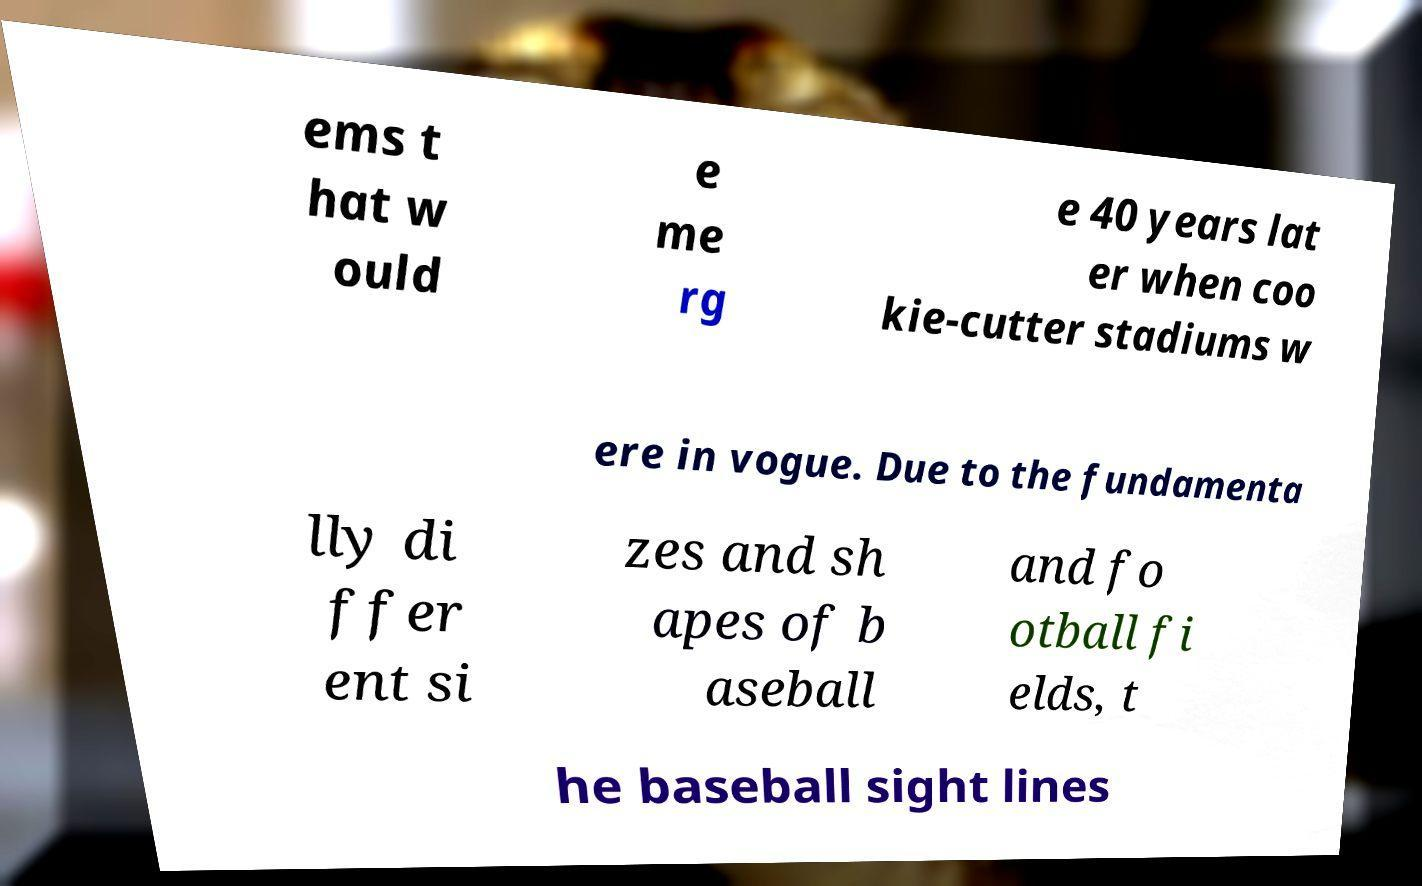Can you read and provide the text displayed in the image?This photo seems to have some interesting text. Can you extract and type it out for me? ems t hat w ould e me rg e 40 years lat er when coo kie-cutter stadiums w ere in vogue. Due to the fundamenta lly di ffer ent si zes and sh apes of b aseball and fo otball fi elds, t he baseball sight lines 